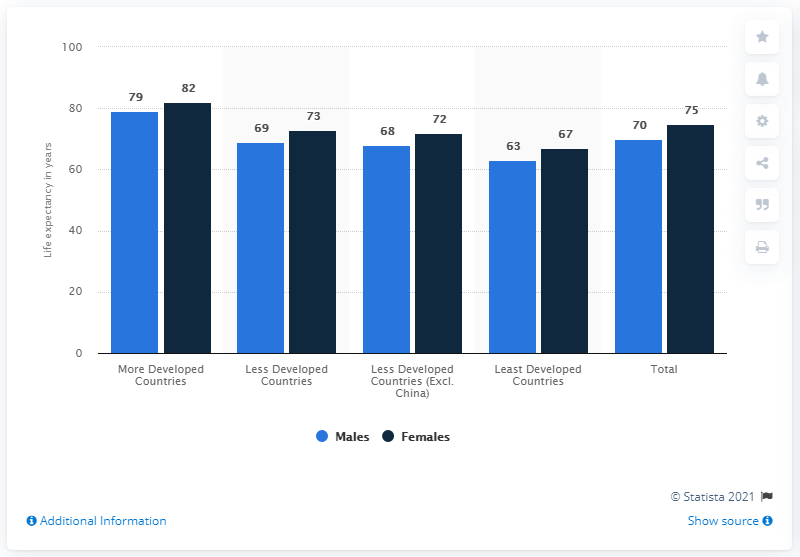Specify some key components in this picture. The difference in life expectancy rates between males and females is the minimum among all countries, with a minimum value of 3 years. According to data, the average life expectancy rate for male residents in Least Developed Countries is 63 years old. 